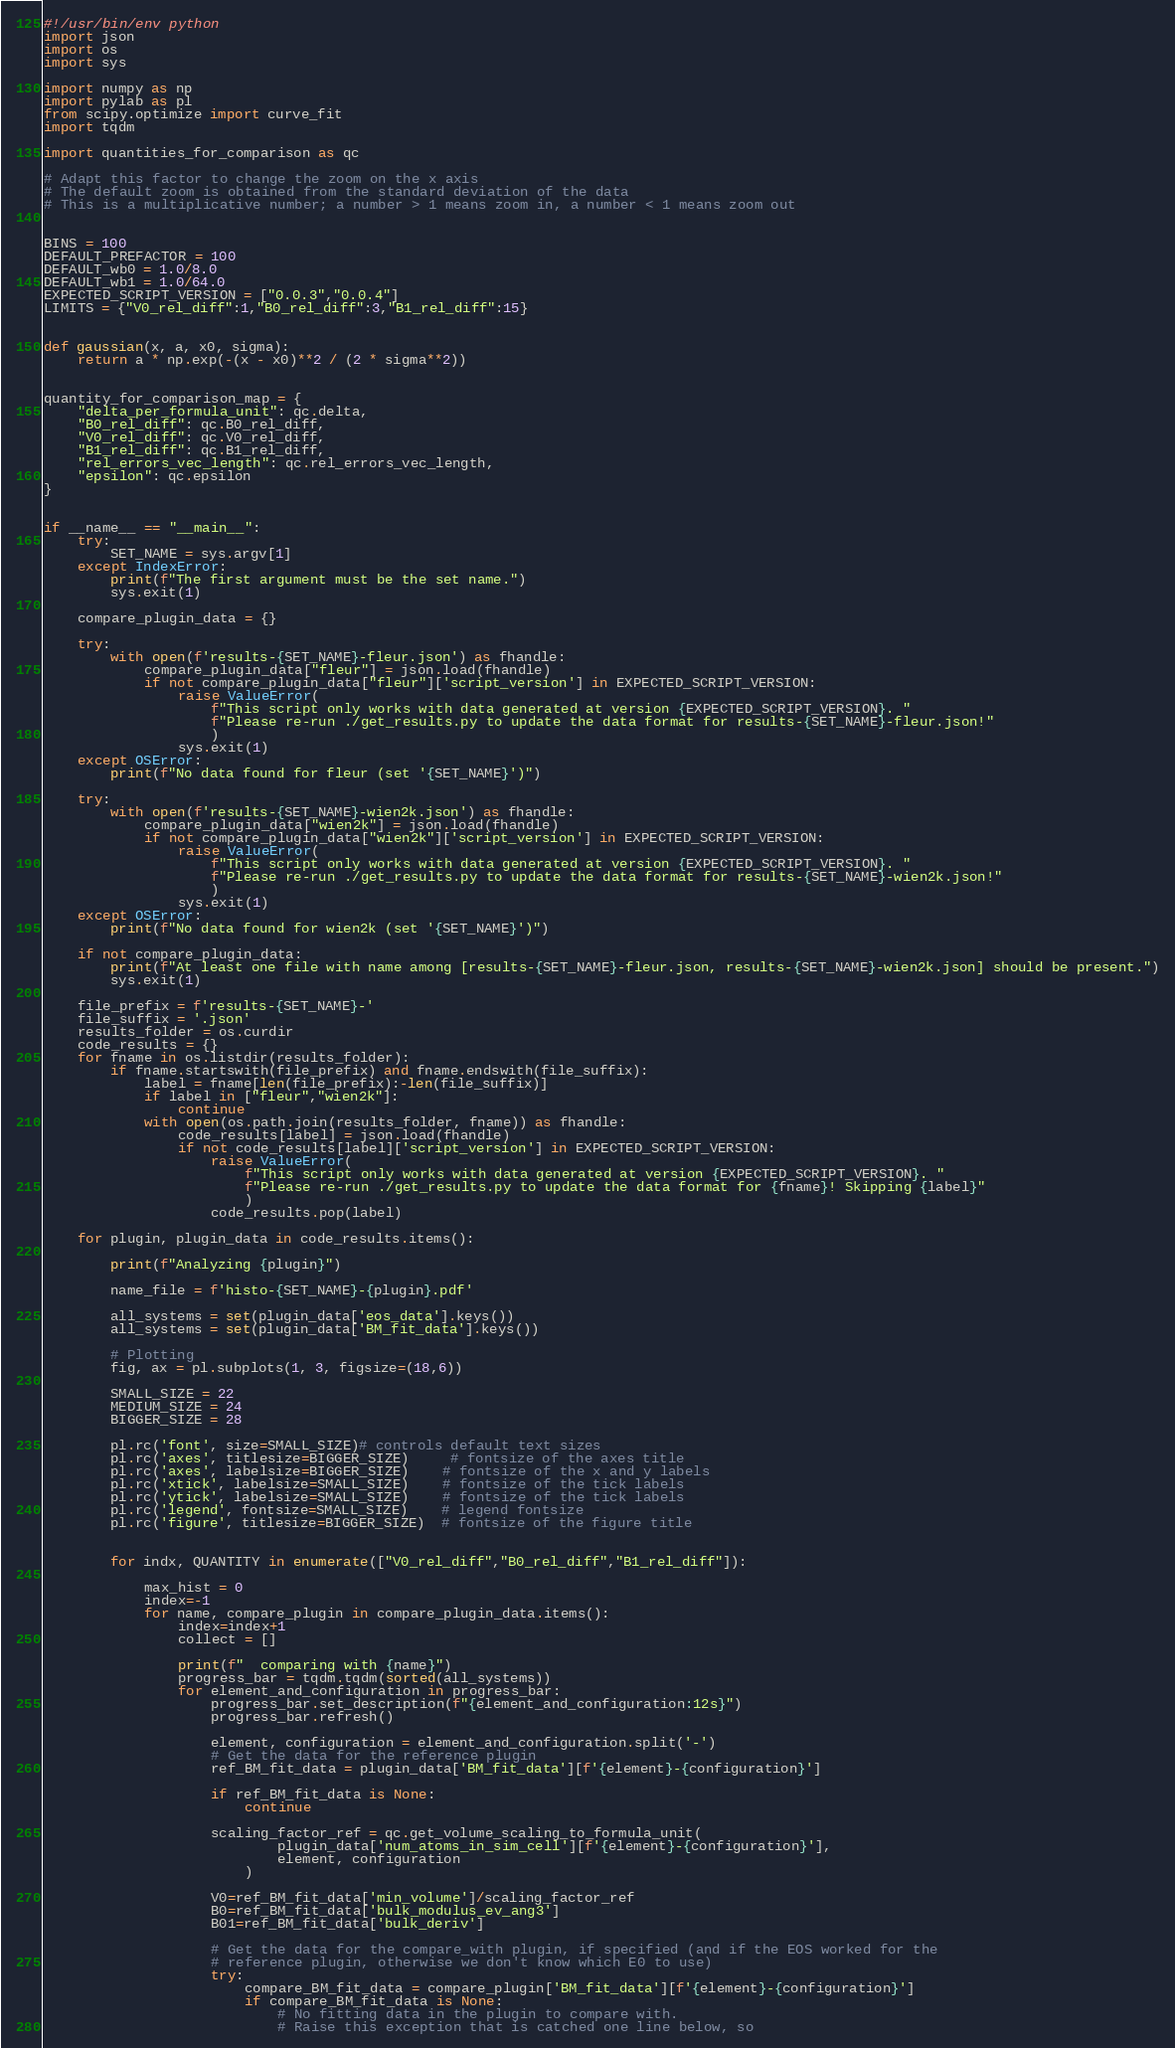<code> <loc_0><loc_0><loc_500><loc_500><_Python_>#!/usr/bin/env python
import json
import os
import sys

import numpy as np
import pylab as pl
from scipy.optimize import curve_fit
import tqdm

import quantities_for_comparison as qc

# Adapt this factor to change the zoom on the x axis
# The default zoom is obtained from the standard deviation of the data
# This is a multiplicative number; a number > 1 means zoom in, a number < 1 means zoom out


BINS = 100
DEFAULT_PREFACTOR = 100
DEFAULT_wb0 = 1.0/8.0
DEFAULT_wb1 = 1.0/64.0
EXPECTED_SCRIPT_VERSION = ["0.0.3","0.0.4"]
LIMITS = {"V0_rel_diff":1,"B0_rel_diff":3,"B1_rel_diff":15}


def gaussian(x, a, x0, sigma):
    return a * np.exp(-(x - x0)**2 / (2 * sigma**2))


quantity_for_comparison_map = {
    "delta_per_formula_unit": qc.delta,
    "B0_rel_diff": qc.B0_rel_diff,
    "V0_rel_diff": qc.V0_rel_diff,
    "B1_rel_diff": qc.B1_rel_diff,
    "rel_errors_vec_length": qc.rel_errors_vec_length,
    "epsilon": qc.epsilon
}


if __name__ == "__main__":
    try:
        SET_NAME = sys.argv[1]
    except IndexError:
        print(f"The first argument must be the set name.")
        sys.exit(1)

    compare_plugin_data = {}
    
    try:
        with open(f'results-{SET_NAME}-fleur.json') as fhandle:
            compare_plugin_data["fleur"] = json.load(fhandle)
            if not compare_plugin_data["fleur"]['script_version'] in EXPECTED_SCRIPT_VERSION:
                raise ValueError(
                    f"This script only works with data generated at version {EXPECTED_SCRIPT_VERSION}. "
                    f"Please re-run ./get_results.py to update the data format for results-{SET_NAME}-fleur.json!"
                    )
                sys.exit(1)
    except OSError:
        print(f"No data found for fleur (set '{SET_NAME}')")

    try:
        with open(f'results-{SET_NAME}-wien2k.json') as fhandle:
            compare_plugin_data["wien2k"] = json.load(fhandle)
            if not compare_plugin_data["wien2k"]['script_version'] in EXPECTED_SCRIPT_VERSION:
                raise ValueError(
                    f"This script only works with data generated at version {EXPECTED_SCRIPT_VERSION}. "
                    f"Please re-run ./get_results.py to update the data format for results-{SET_NAME}-wien2k.json!"
                    )
                sys.exit(1)
    except OSError:
        print(f"No data found for wien2k (set '{SET_NAME}')")

    if not compare_plugin_data:
        print(f"At least one file with name among [results-{SET_NAME}-fleur.json, results-{SET_NAME}-wien2k.json] should be present.")
        sys.exit(1)

    file_prefix = f'results-{SET_NAME}-'
    file_suffix = '.json'
    results_folder = os.curdir
    code_results = {}
    for fname in os.listdir(results_folder):
        if fname.startswith(file_prefix) and fname.endswith(file_suffix):
            label = fname[len(file_prefix):-len(file_suffix)]
            if label in ["fleur","wien2k"]:
                continue
            with open(os.path.join(results_folder, fname)) as fhandle:
                code_results[label] = json.load(fhandle)
                if not code_results[label]['script_version'] in EXPECTED_SCRIPT_VERSION:
                    raise ValueError(
                        f"This script only works with data generated at version {EXPECTED_SCRIPT_VERSION}. "
                        f"Please re-run ./get_results.py to update the data format for {fname}! Skipping {label}"
                        )
                    code_results.pop(label)
    
    for plugin, plugin_data in code_results.items():
 
        print(f"Analyzing {plugin}")

        name_file = f'histo-{SET_NAME}-{plugin}.pdf'

        all_systems = set(plugin_data['eos_data'].keys())
        all_systems = set(plugin_data['BM_fit_data'].keys())

        # Plotting
        fig, ax = pl.subplots(1, 3, figsize=(18,6))

        SMALL_SIZE = 22
        MEDIUM_SIZE = 24
        BIGGER_SIZE = 28

        pl.rc('font', size=SMALL_SIZE)# controls default text sizes
        pl.rc('axes', titlesize=BIGGER_SIZE)     # fontsize of the axes title
        pl.rc('axes', labelsize=BIGGER_SIZE)    # fontsize of the x and y labels
        pl.rc('xtick', labelsize=SMALL_SIZE)    # fontsize of the tick labels
        pl.rc('ytick', labelsize=SMALL_SIZE)    # fontsize of the tick labels
        pl.rc('legend', fontsize=SMALL_SIZE)    # legend fontsize
        pl.rc('figure', titlesize=BIGGER_SIZE)  # fontsize of the figure title

        
        for indx, QUANTITY in enumerate(["V0_rel_diff","B0_rel_diff","B1_rel_diff"]):

            max_hist = 0
            index=-1
            for name, compare_plugin in compare_plugin_data.items():
                index=index+1
                collect = []

                print(f"  comparing with {name}")
                progress_bar = tqdm.tqdm(sorted(all_systems))
                for element_and_configuration in progress_bar:
                    progress_bar.set_description(f"{element_and_configuration:12s}")
                    progress_bar.refresh()

                    element, configuration = element_and_configuration.split('-')
                    # Get the data for the reference plugin
                    ref_BM_fit_data = plugin_data['BM_fit_data'][f'{element}-{configuration}']
                
                    if ref_BM_fit_data is None:
                        continue
               
                    scaling_factor_ref = qc.get_volume_scaling_to_formula_unit(
                            plugin_data['num_atoms_in_sim_cell'][f'{element}-{configuration}'],
                            element, configuration
                        )

                    V0=ref_BM_fit_data['min_volume']/scaling_factor_ref
                    B0=ref_BM_fit_data['bulk_modulus_ev_ang3']
                    B01=ref_BM_fit_data['bulk_deriv']

                    # Get the data for the compare_with plugin, if specified (and if the EOS worked for the 
                    # reference plugin, otherwise we don't know which E0 to use)
                    try:
                        compare_BM_fit_data = compare_plugin['BM_fit_data'][f'{element}-{configuration}']
                        if compare_BM_fit_data is None:
                            # No fitting data in the plugin to compare with.
                            # Raise this exception that is catched one line below, so</code> 